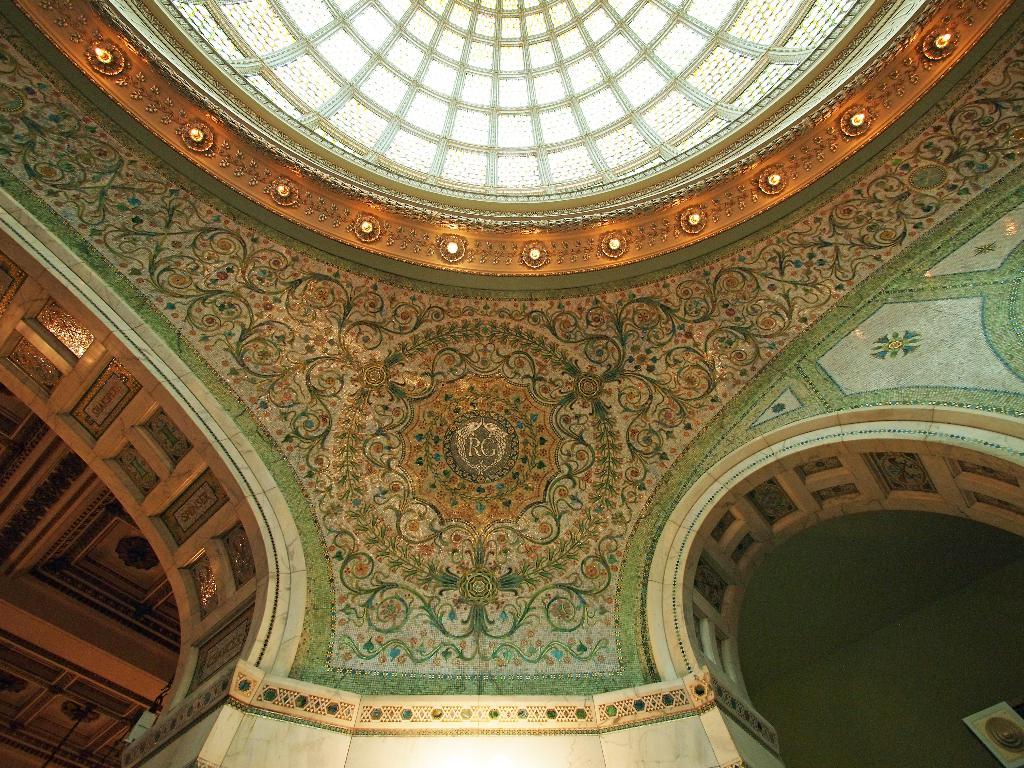What can be seen on the walls in the image? The walls in the image have a design. What is present on the ceiling in the image? There are lights on the ceiling in the image. Can you see any ants crawling on the walls in the image? There are no ants visible in the image; the focus is on the design of the walls and the lights on the ceiling. 